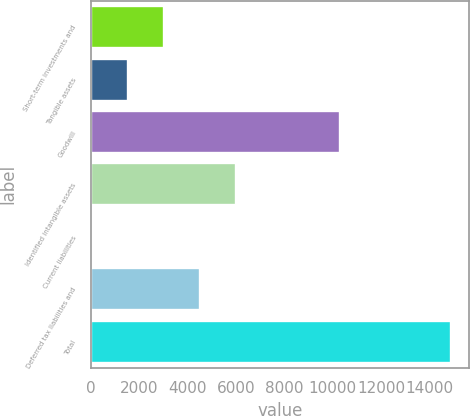Convert chart. <chart><loc_0><loc_0><loc_500><loc_500><bar_chart><fcel>Short-term investments and<fcel>Tangible assets<fcel>Goodwill<fcel>Identified intangible assets<fcel>Current liabilities<fcel>Deferred tax liabilities and<fcel>Total<nl><fcel>3030.2<fcel>1549.6<fcel>10283<fcel>5991.4<fcel>69<fcel>4510.8<fcel>14875<nl></chart> 